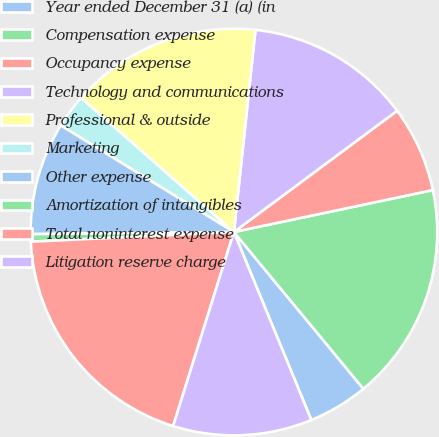<chart> <loc_0><loc_0><loc_500><loc_500><pie_chart><fcel>Year ended December 31 (a) (in<fcel>Compensation expense<fcel>Occupancy expense<fcel>Technology and communications<fcel>Professional & outside<fcel>Marketing<fcel>Other expense<fcel>Amortization of intangibles<fcel>Total noninterest expense<fcel>Litigation reserve charge<nl><fcel>4.77%<fcel>17.32%<fcel>6.86%<fcel>13.14%<fcel>15.23%<fcel>2.68%<fcel>8.95%<fcel>0.59%<fcel>19.41%<fcel>11.05%<nl></chart> 